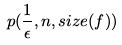<formula> <loc_0><loc_0><loc_500><loc_500>p ( \frac { 1 } { \epsilon } , n , s i z e ( f ) )</formula> 